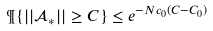<formula> <loc_0><loc_0><loc_500><loc_500>\P \{ | | \mathcal { A } _ { * } | | \geq C \} \leq e ^ { - N c _ { 0 } ( C - C _ { 0 } ) }</formula> 